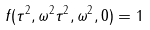<formula> <loc_0><loc_0><loc_500><loc_500>f ( \tau ^ { 2 } , \omega ^ { 2 } \tau ^ { 2 } , \omega ^ { 2 } , 0 ) = 1</formula> 